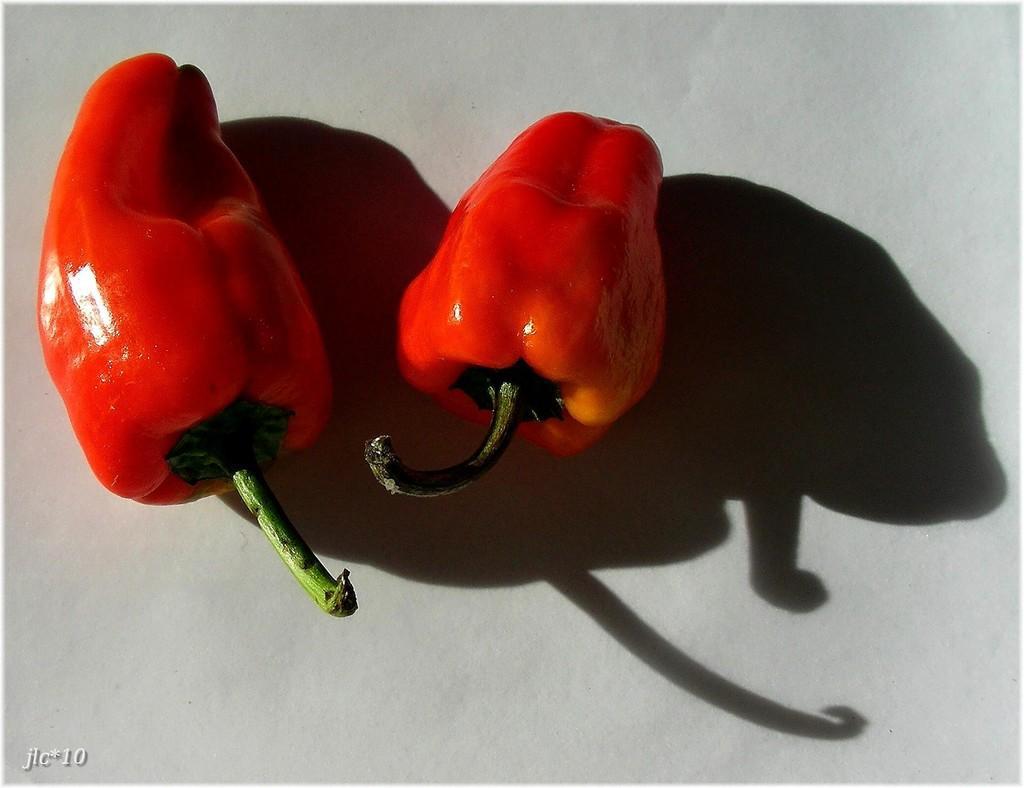Could you give a brief overview of what you see in this image? In this picture we can see there are two red capsicums on the white object. On the image there is a watermark. 